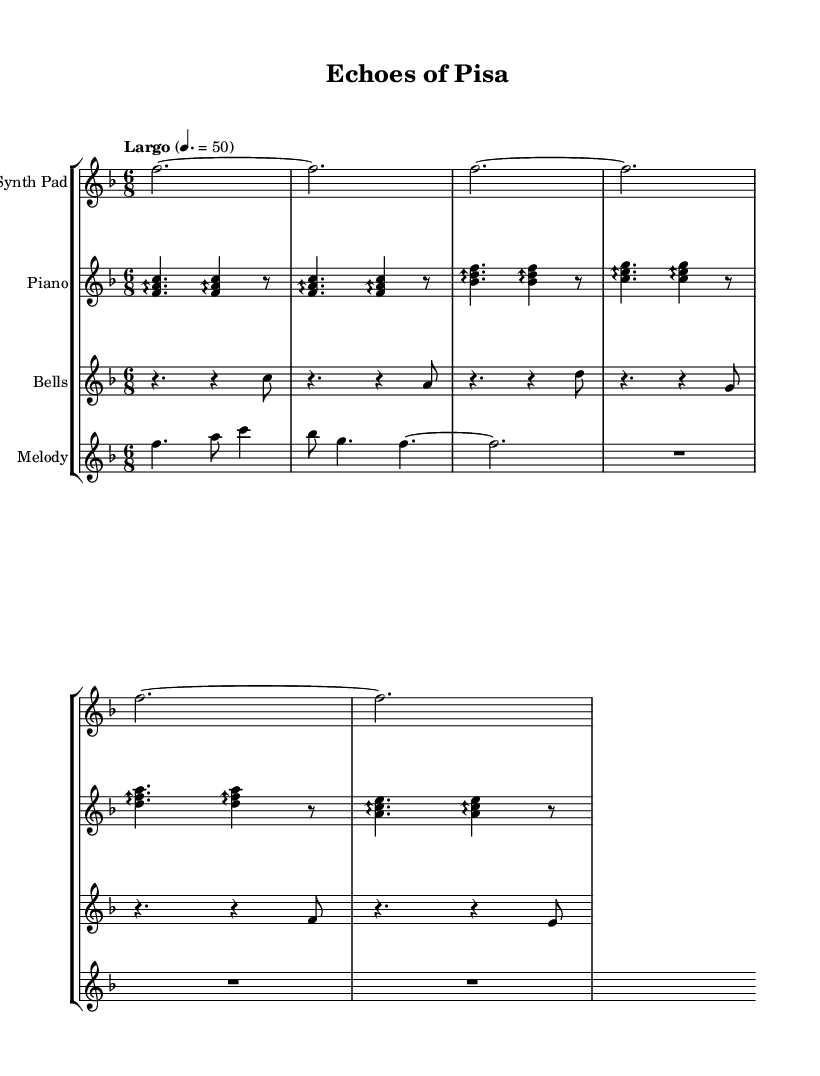What is the key signature of this music? The key signature is F major, which has one flat (B flat). This can be identified from the key signature indicated at the beginning of the music sheet.
Answer: F major What is the time signature of this music? The time signature is 6/8, which indicates six eighth notes per measure. This is visible at the beginning of the music sheet, right after the key signature.
Answer: 6/8 What is the tempo marking for this piece? The tempo marking is Largo, set at a quarter note equals 50. This can be found written above the staff, alongside the rhythmic indications.
Answer: Largo How many instruments are featured in this score? There are four instruments: Synth Pad, Piano, Bells, and Melody. Each instrument is labeled at the beginning of its corresponding staff in the music sheet.
Answer: Four Which instrument plays the melody line? The instrument that plays the melody is labeled as "Melody." You can find this indicated clearly at the beginning of the respective staff in the score.
Answer: Melody What rhythmic value is predominant in the melody? The predominant rhythmic value in the melody is a dotted quarter note followed by an eighth note. This can be seen in the first measure of the melody staff.
Answer: Dotted quarter note Which two notes are highlighted in the bells section? The two notes prominently featured in the bells section are C and A. These notes are first played in the sequence, especially noticeable in the initial measures of the bells staff.
Answer: C and A 